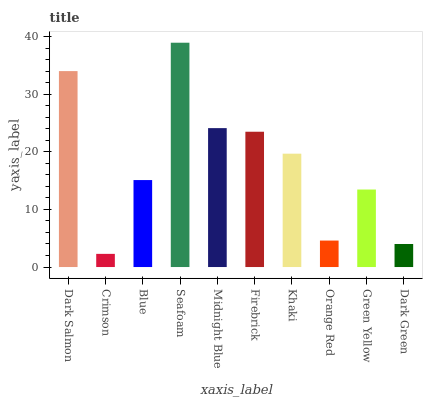Is Blue the minimum?
Answer yes or no. No. Is Blue the maximum?
Answer yes or no. No. Is Blue greater than Crimson?
Answer yes or no. Yes. Is Crimson less than Blue?
Answer yes or no. Yes. Is Crimson greater than Blue?
Answer yes or no. No. Is Blue less than Crimson?
Answer yes or no. No. Is Khaki the high median?
Answer yes or no. Yes. Is Blue the low median?
Answer yes or no. Yes. Is Seafoam the high median?
Answer yes or no. No. Is Midnight Blue the low median?
Answer yes or no. No. 